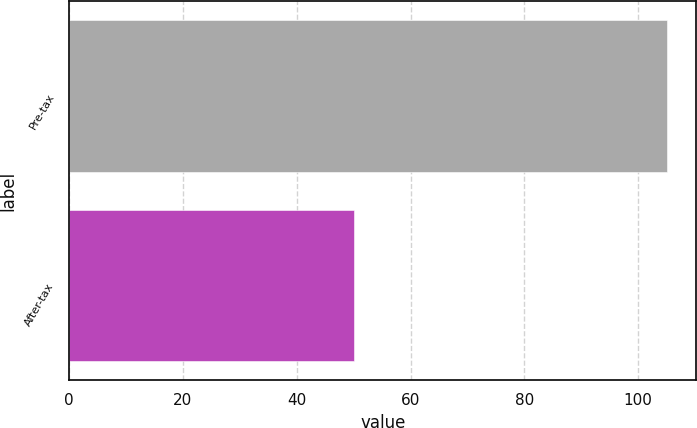<chart> <loc_0><loc_0><loc_500><loc_500><bar_chart><fcel>Pre-tax<fcel>After-tax<nl><fcel>105<fcel>50<nl></chart> 